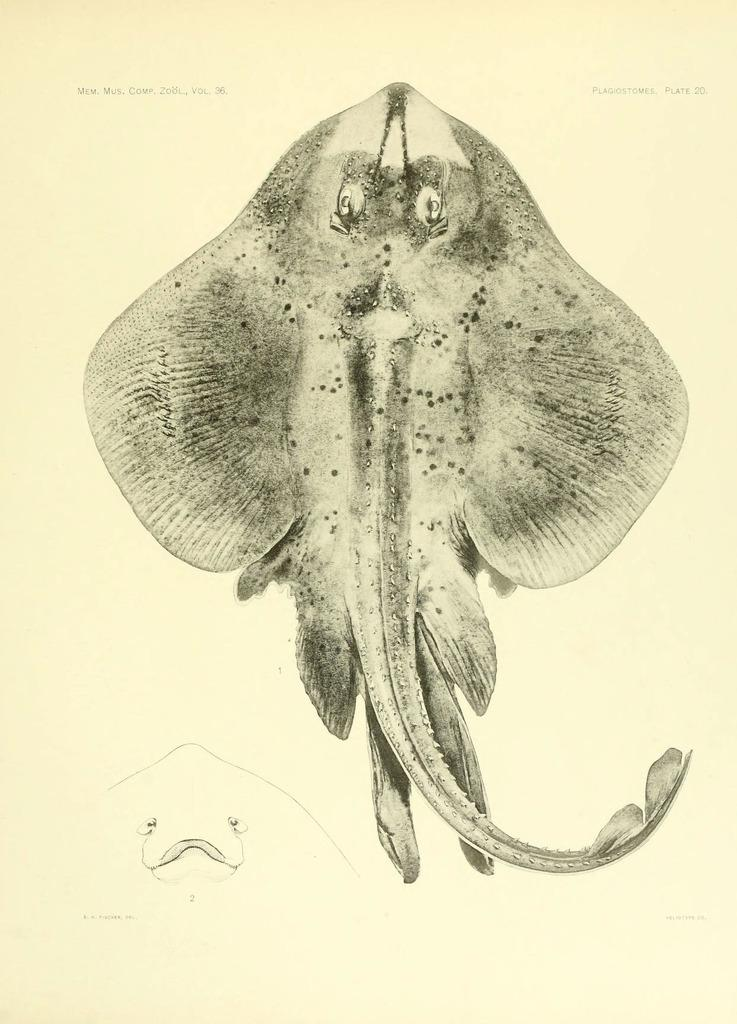What is depicted in the image? The image is a drawing of an animal. What color is the background of the image? The background of the image is cream-colored. How many points are on the wood in the image? There is no wood present in the image, and therefore no points to count. 